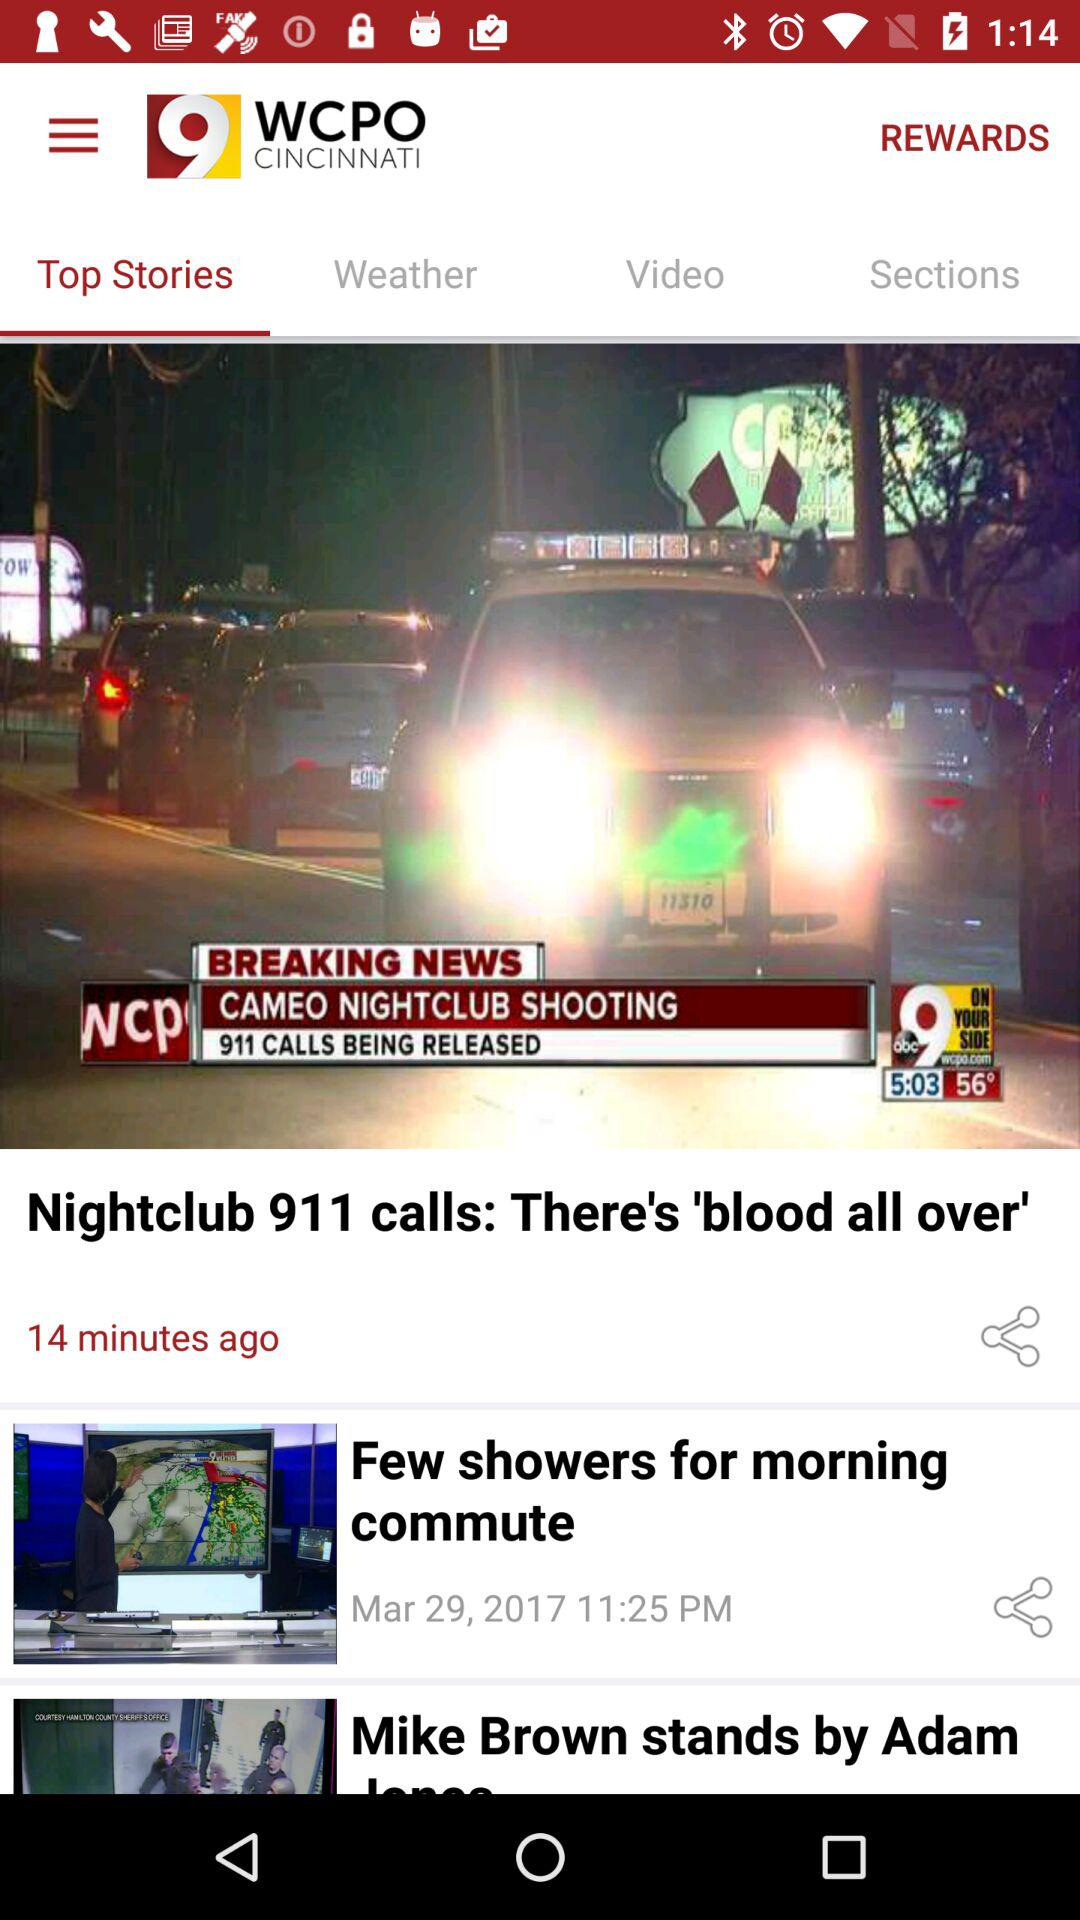At what time was the news about the nightclub 911 calls: there's 'blood all over' 911 posted? The news was posted 14 minutes ago. 